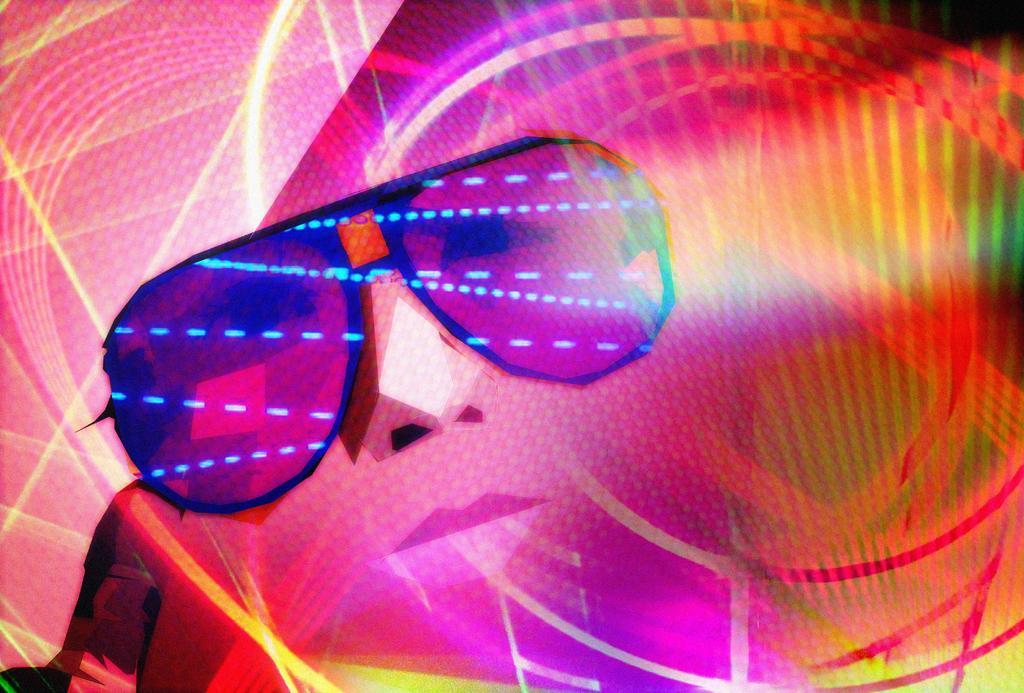Describe this image in one or two sentences. In this image we can see there is an edited image with person face and goggles on her face. 